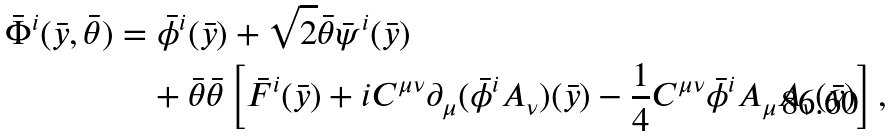<formula> <loc_0><loc_0><loc_500><loc_500>\bar { \Phi } ^ { i } ( \bar { y } , \bar { \theta } ) & = \bar { \phi } ^ { i } ( \bar { y } ) + \sqrt { 2 } \bar { \theta } \bar { \psi } ^ { i } ( \bar { y } ) \\ & \quad + \bar { \theta } \bar { \theta } \left [ \bar { F } ^ { i } ( \bar { y } ) + i C ^ { \mu \nu } \partial _ { \mu } ( \bar { \phi } ^ { i } A _ { \nu } ) ( \bar { y } ) - \frac { 1 } { 4 } C ^ { \mu \nu } \bar { \phi } ^ { i } A _ { \mu } A _ { \nu } ( \bar { y } ) \right ] ,</formula> 